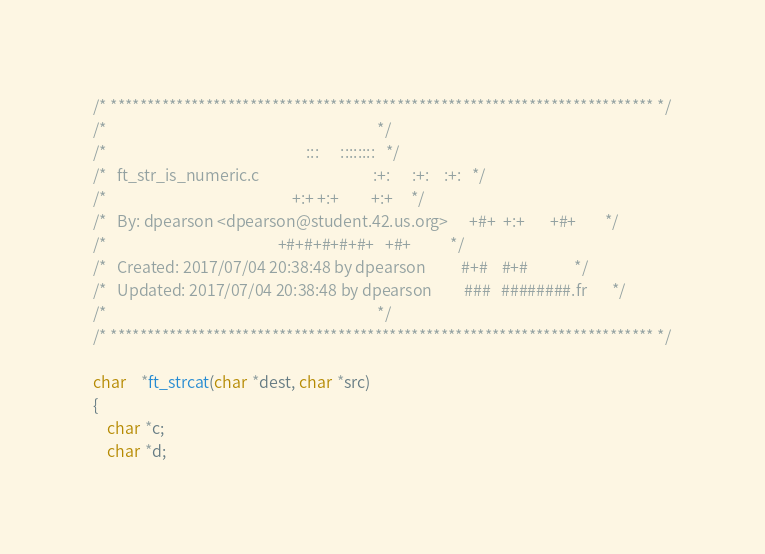Convert code to text. <code><loc_0><loc_0><loc_500><loc_500><_C_>/* ************************************************************************** */
/*                                                                            */
/*                                                        :::      ::::::::   */
/*   ft_str_is_numeric.c                                :+:      :+:    :+:   */
/*                                                    +:+ +:+         +:+     */
/*   By: dpearson <dpearson@student.42.us.org>      +#+  +:+       +#+        */
/*                                                +#+#+#+#+#+   +#+           */
/*   Created: 2017/07/04 20:38:48 by dpearson          #+#    #+#             */
/*   Updated: 2017/07/04 20:38:48 by dpearson         ###   ########.fr       */
/*                                                                            */
/* ************************************************************************** */

char	*ft_strcat(char *dest, char *src)
{
	char *c;
	char *d;
</code> 